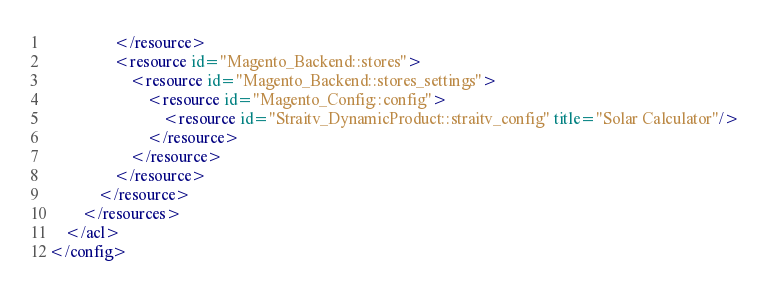<code> <loc_0><loc_0><loc_500><loc_500><_XML_>                </resource>
                <resource id="Magento_Backend::stores">
                    <resource id="Magento_Backend::stores_settings">
                        <resource id="Magento_Config::config">
                            <resource id="Straitv_DynamicProduct::straitv_config" title="Solar Calculator"/>
                        </resource>
                    </resource>
                </resource>
            </resource>
        </resources>
    </acl>
</config></code> 